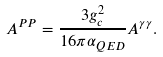<formula> <loc_0><loc_0><loc_500><loc_500>A ^ { P P } = \frac { 3 g _ { c } ^ { 2 } } { 1 6 \pi \alpha _ { Q E D } } A ^ { \gamma \gamma } .</formula> 